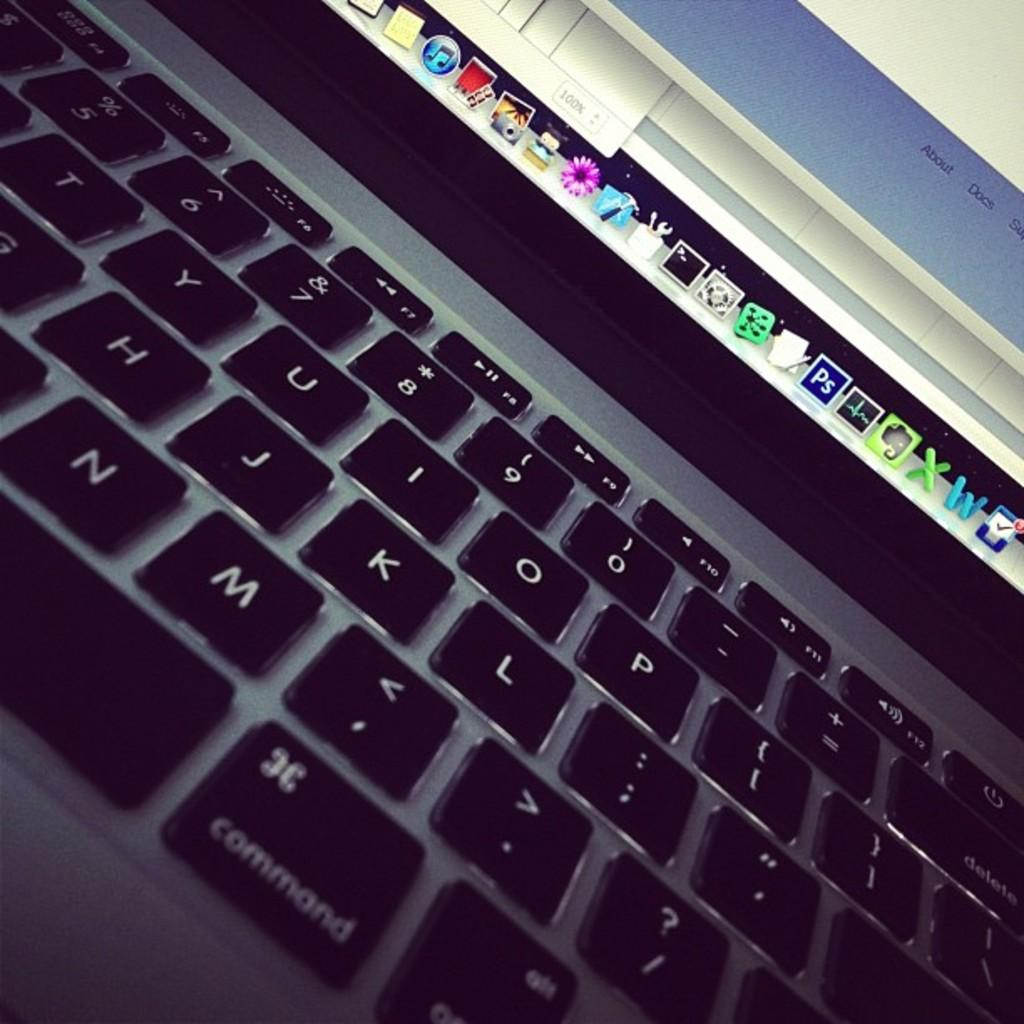<image>
Summarize the visual content of the image. Part of a computer keyboard is shown with the Command key in the front. 